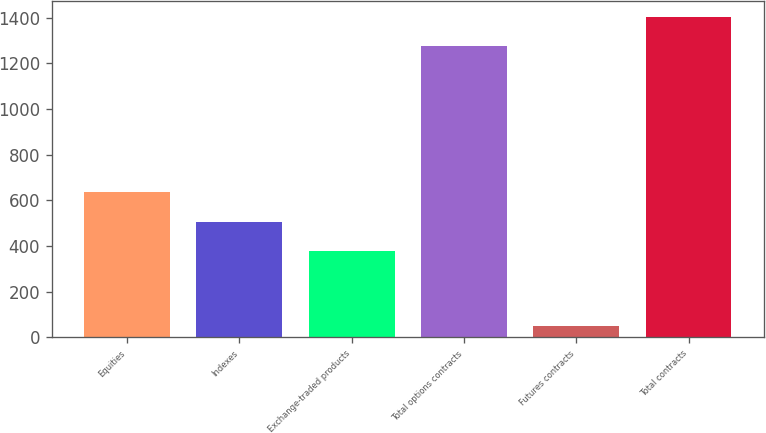Convert chart to OTSL. <chart><loc_0><loc_0><loc_500><loc_500><bar_chart><fcel>Equities<fcel>Indexes<fcel>Exchange-traded products<fcel>Total options contracts<fcel>Futures contracts<fcel>Total contracts<nl><fcel>634.66<fcel>507.18<fcel>379.7<fcel>1274.8<fcel>50.6<fcel>1402.28<nl></chart> 